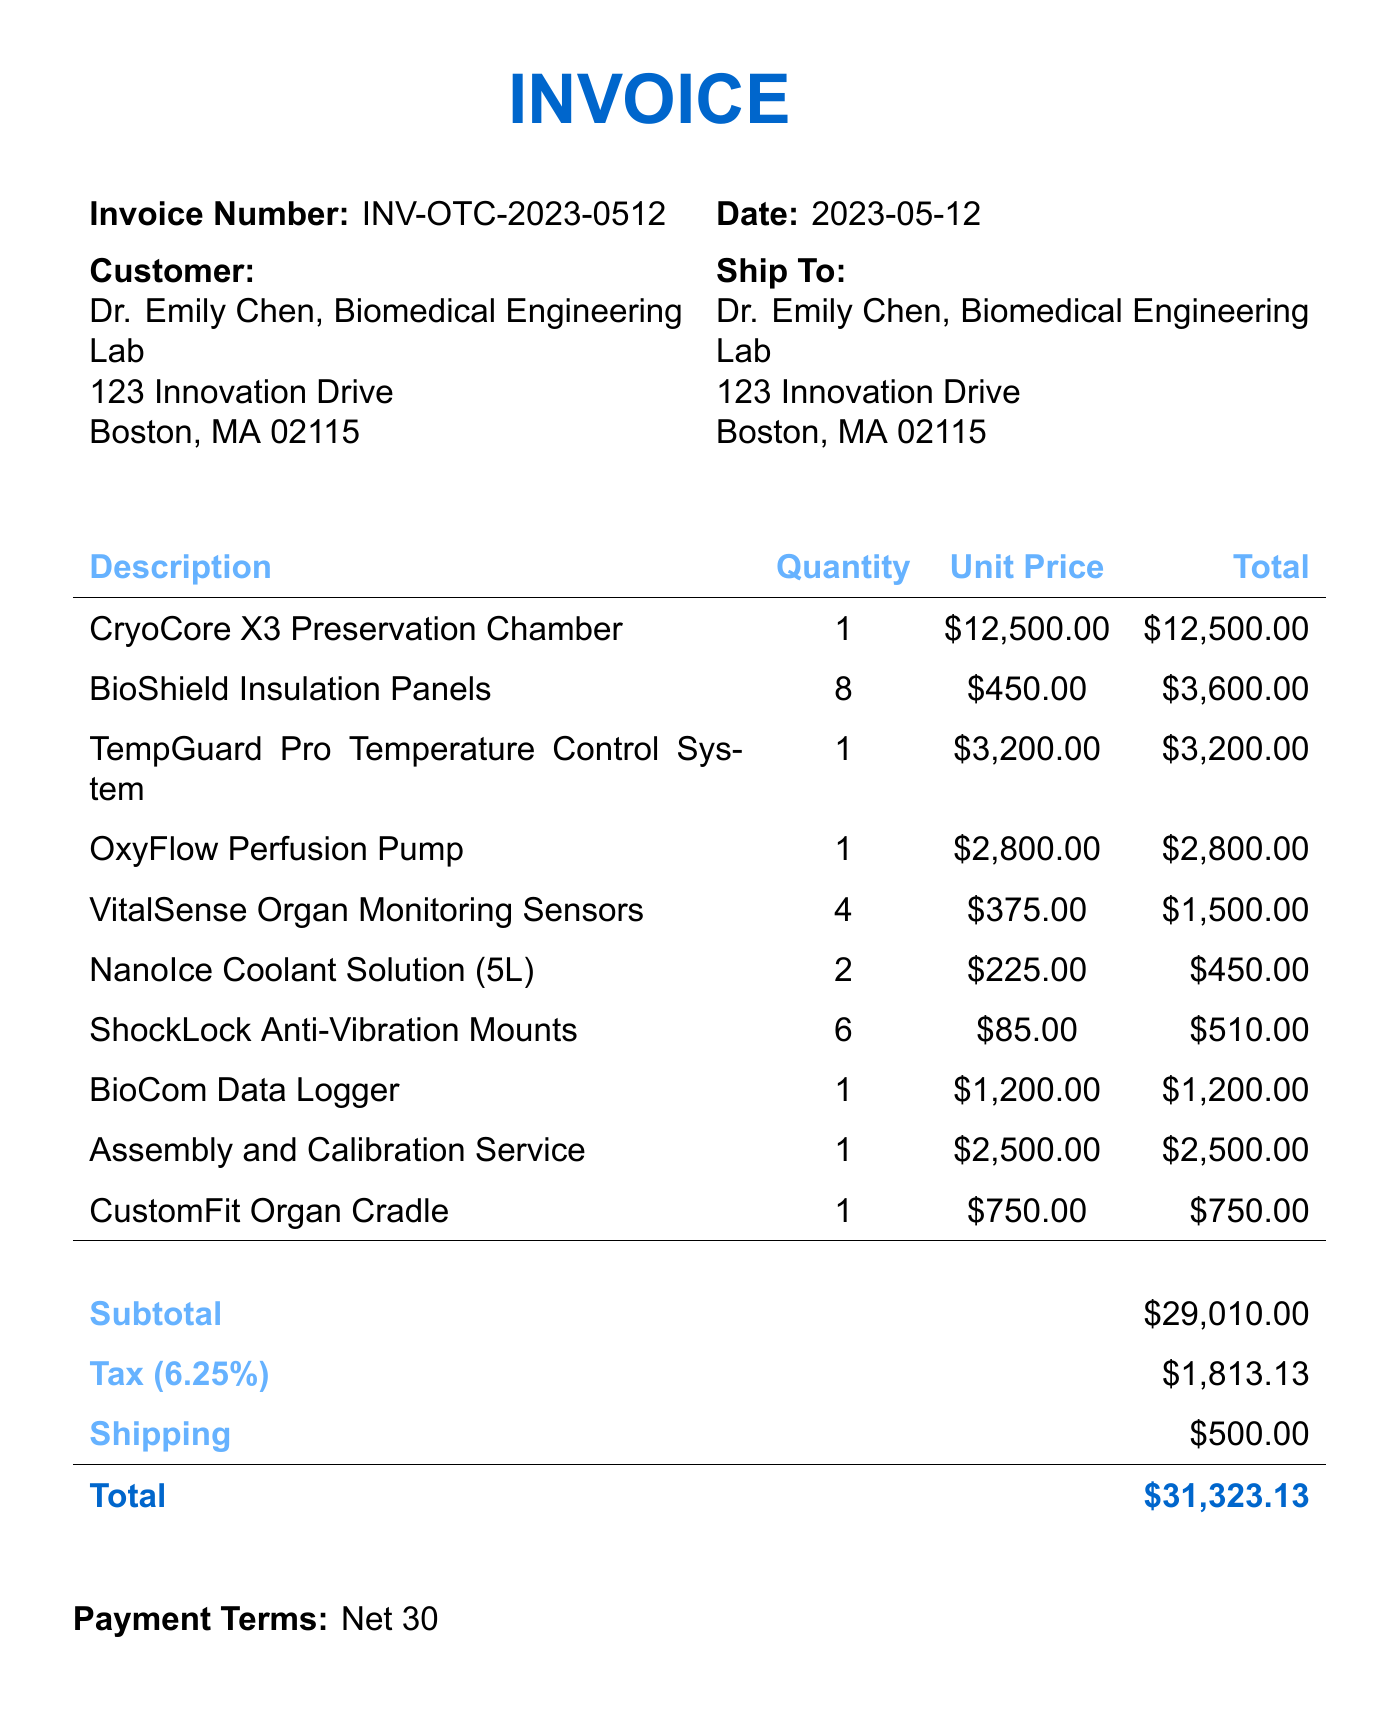What is the invoice number? The invoice number is stated clearly in the document as a unique identifier for the transaction.
Answer: INV-OTC-2023-0512 What is the date of the invoice? The date represents when the invoice was issued. It can be found at the top of the document.
Answer: 2023-05-12 Who is the customer? The customer's name is provided in the document, indicating to whom the invoice is addressed.
Answer: Dr. Emily Chen, Biomedical Engineering Lab What is the total amount due? The total amount is the final sum after adding the subtotal, tax, and shipping costs.
Answer: $31,323.13 How many BioShield Insulation Panels were ordered? The quantity of BioShield Insulation Panels can be found in the itemized list of products.
Answer: 8 What is the unit price of the OxyFlow Perfusion Pump? The unit price indicates the cost for one OxyFlow Perfusion Pump, provided in the itemized section.
Answer: $2,800.00 What is the subtotal before tax and shipping? The subtotal is the sum of all item costs before any additional fees or taxes.
Answer: $29,010.00 What kind of service is included in the invoice? The service mentioned is specifically related to the assembly and calibration of the product.
Answer: Assembly and Calibration Service What payment terms are specified in the document? Payment terms indicate the conditions under which the payment should be made.
Answer: Net 30 